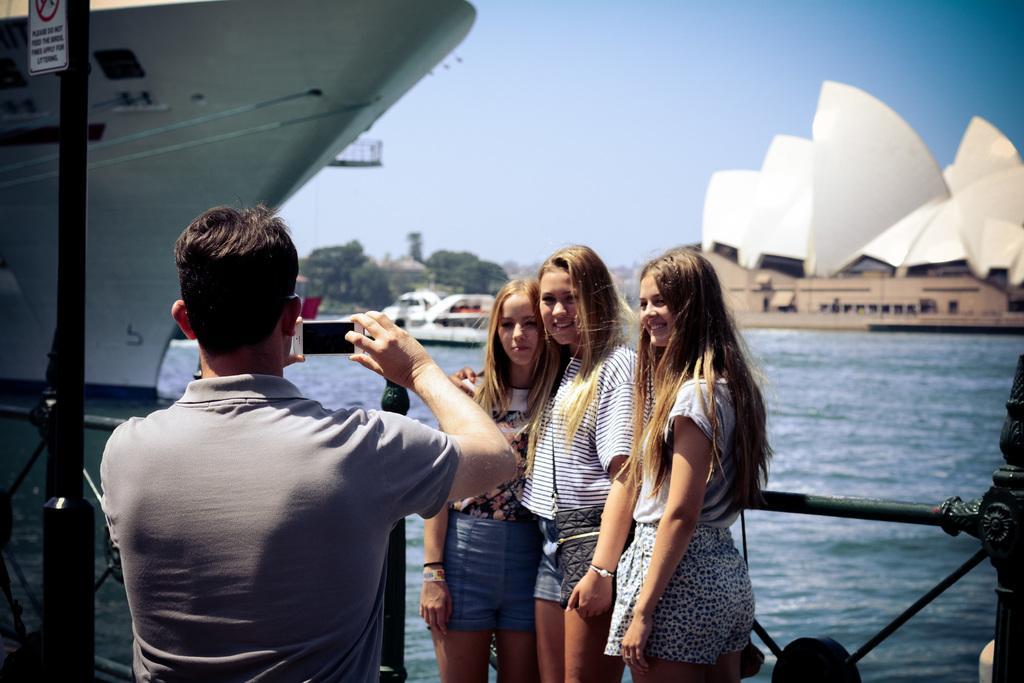Can you describe this image briefly? In this picture, we can see there are four people standing on the path and a man is holding a mobile. Behind the people there is a fence, ship on the water, trees, sky and a Sydney opera house. 